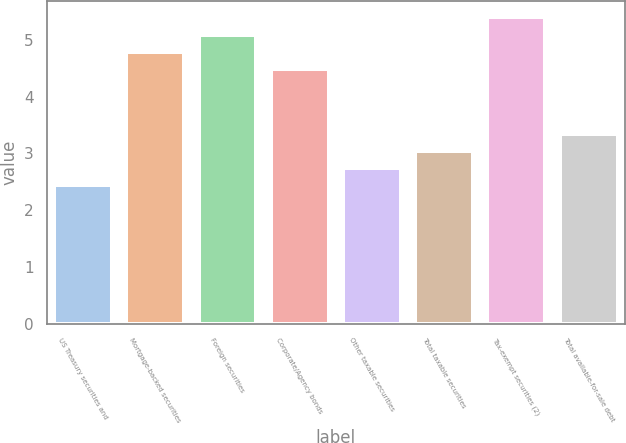<chart> <loc_0><loc_0><loc_500><loc_500><bar_chart><fcel>US Treasury securities and<fcel>Mortgage-backed securities<fcel>Foreign securities<fcel>Corporate/Agency bonds<fcel>Other taxable securities<fcel>Total taxable securities<fcel>Tax-exempt securities (2)<fcel>Total available-for-sale debt<nl><fcel>2.45<fcel>4.78<fcel>5.08<fcel>4.48<fcel>2.75<fcel>3.05<fcel>5.41<fcel>3.35<nl></chart> 